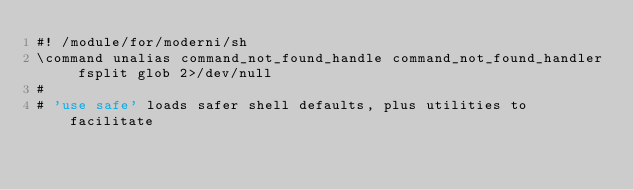<code> <loc_0><loc_0><loc_500><loc_500><_ObjectiveC_>#! /module/for/moderni/sh
\command unalias command_not_found_handle command_not_found_handler fsplit glob 2>/dev/null
#
# 'use safe' loads safer shell defaults, plus utilities to facilitate</code> 